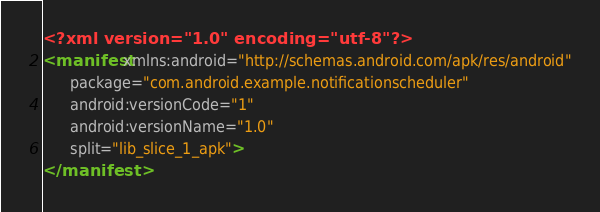Convert code to text. <code><loc_0><loc_0><loc_500><loc_500><_XML_><?xml version="1.0" encoding="utf-8"?>
<manifest xmlns:android="http://schemas.android.com/apk/res/android"
      package="com.android.example.notificationscheduler"
      android:versionCode="1"
      android:versionName="1.0"
      split="lib_slice_1_apk">
</manifest>
</code> 